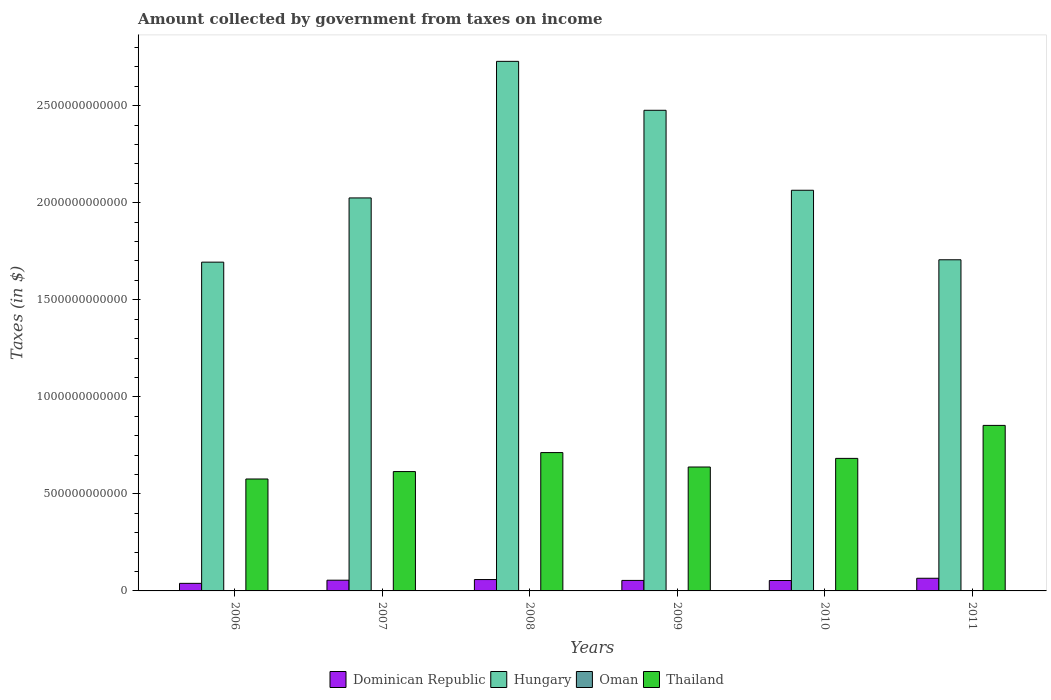How many different coloured bars are there?
Your answer should be compact. 4. How many groups of bars are there?
Your answer should be compact. 6. Are the number of bars on each tick of the X-axis equal?
Offer a terse response. Yes. How many bars are there on the 4th tick from the left?
Keep it short and to the point. 4. How many bars are there on the 3rd tick from the right?
Your answer should be compact. 4. In how many cases, is the number of bars for a given year not equal to the number of legend labels?
Give a very brief answer. 0. What is the amount collected by government from taxes on income in Thailand in 2008?
Your answer should be compact. 7.13e+11. Across all years, what is the maximum amount collected by government from taxes on income in Oman?
Offer a terse response. 3.70e+08. Across all years, what is the minimum amount collected by government from taxes on income in Hungary?
Keep it short and to the point. 1.69e+12. In which year was the amount collected by government from taxes on income in Oman maximum?
Offer a terse response. 2009. What is the total amount collected by government from taxes on income in Oman in the graph?
Provide a succinct answer. 1.43e+09. What is the difference between the amount collected by government from taxes on income in Oman in 2008 and that in 2009?
Your answer should be compact. -1.33e+08. What is the difference between the amount collected by government from taxes on income in Dominican Republic in 2007 and the amount collected by government from taxes on income in Oman in 2011?
Offer a terse response. 5.50e+1. What is the average amount collected by government from taxes on income in Dominican Republic per year?
Your response must be concise. 5.43e+1. In the year 2011, what is the difference between the amount collected by government from taxes on income in Oman and amount collected by government from taxes on income in Thailand?
Offer a very short reply. -8.52e+11. In how many years, is the amount collected by government from taxes on income in Hungary greater than 700000000000 $?
Ensure brevity in your answer.  6. What is the ratio of the amount collected by government from taxes on income in Hungary in 2006 to that in 2010?
Give a very brief answer. 0.82. Is the amount collected by government from taxes on income in Dominican Republic in 2009 less than that in 2011?
Ensure brevity in your answer.  Yes. What is the difference between the highest and the second highest amount collected by government from taxes on income in Hungary?
Provide a succinct answer. 2.52e+11. What is the difference between the highest and the lowest amount collected by government from taxes on income in Dominican Republic?
Your answer should be compact. 2.62e+1. In how many years, is the amount collected by government from taxes on income in Dominican Republic greater than the average amount collected by government from taxes on income in Dominican Republic taken over all years?
Provide a succinct answer. 3. Is the sum of the amount collected by government from taxes on income in Oman in 2009 and 2010 greater than the maximum amount collected by government from taxes on income in Thailand across all years?
Keep it short and to the point. No. Is it the case that in every year, the sum of the amount collected by government from taxes on income in Thailand and amount collected by government from taxes on income in Oman is greater than the sum of amount collected by government from taxes on income in Hungary and amount collected by government from taxes on income in Dominican Republic?
Ensure brevity in your answer.  No. What does the 1st bar from the left in 2011 represents?
Keep it short and to the point. Dominican Republic. What does the 3rd bar from the right in 2009 represents?
Offer a very short reply. Hungary. Are all the bars in the graph horizontal?
Give a very brief answer. No. What is the difference between two consecutive major ticks on the Y-axis?
Your answer should be very brief. 5.00e+11. Does the graph contain grids?
Your answer should be compact. No. How many legend labels are there?
Ensure brevity in your answer.  4. What is the title of the graph?
Your response must be concise. Amount collected by government from taxes on income. Does "Ecuador" appear as one of the legend labels in the graph?
Ensure brevity in your answer.  No. What is the label or title of the X-axis?
Give a very brief answer. Years. What is the label or title of the Y-axis?
Provide a succinct answer. Taxes (in $). What is the Taxes (in $) in Dominican Republic in 2006?
Ensure brevity in your answer.  3.90e+1. What is the Taxes (in $) in Hungary in 2006?
Provide a short and direct response. 1.69e+12. What is the Taxes (in $) in Oman in 2006?
Offer a terse response. 8.54e+07. What is the Taxes (in $) in Thailand in 2006?
Keep it short and to the point. 5.77e+11. What is the Taxes (in $) in Dominican Republic in 2007?
Your response must be concise. 5.52e+1. What is the Taxes (in $) in Hungary in 2007?
Your answer should be very brief. 2.02e+12. What is the Taxes (in $) of Oman in 2007?
Make the answer very short. 1.87e+08. What is the Taxes (in $) of Thailand in 2007?
Keep it short and to the point. 6.15e+11. What is the Taxes (in $) in Dominican Republic in 2008?
Your answer should be compact. 5.85e+1. What is the Taxes (in $) of Hungary in 2008?
Provide a succinct answer. 2.73e+12. What is the Taxes (in $) in Oman in 2008?
Provide a succinct answer. 2.37e+08. What is the Taxes (in $) of Thailand in 2008?
Keep it short and to the point. 7.13e+11. What is the Taxes (in $) of Dominican Republic in 2009?
Ensure brevity in your answer.  5.41e+1. What is the Taxes (in $) in Hungary in 2009?
Provide a short and direct response. 2.48e+12. What is the Taxes (in $) in Oman in 2009?
Make the answer very short. 3.70e+08. What is the Taxes (in $) of Thailand in 2009?
Offer a very short reply. 6.38e+11. What is the Taxes (in $) of Dominican Republic in 2010?
Your response must be concise. 5.36e+1. What is the Taxes (in $) of Hungary in 2010?
Your answer should be very brief. 2.06e+12. What is the Taxes (in $) in Oman in 2010?
Your answer should be compact. 2.73e+08. What is the Taxes (in $) of Thailand in 2010?
Keep it short and to the point. 6.83e+11. What is the Taxes (in $) in Dominican Republic in 2011?
Your answer should be very brief. 6.52e+1. What is the Taxes (in $) of Hungary in 2011?
Your response must be concise. 1.71e+12. What is the Taxes (in $) in Oman in 2011?
Keep it short and to the point. 2.82e+08. What is the Taxes (in $) in Thailand in 2011?
Ensure brevity in your answer.  8.53e+11. Across all years, what is the maximum Taxes (in $) in Dominican Republic?
Ensure brevity in your answer.  6.52e+1. Across all years, what is the maximum Taxes (in $) of Hungary?
Provide a short and direct response. 2.73e+12. Across all years, what is the maximum Taxes (in $) in Oman?
Offer a very short reply. 3.70e+08. Across all years, what is the maximum Taxes (in $) in Thailand?
Provide a short and direct response. 8.53e+11. Across all years, what is the minimum Taxes (in $) in Dominican Republic?
Keep it short and to the point. 3.90e+1. Across all years, what is the minimum Taxes (in $) in Hungary?
Ensure brevity in your answer.  1.69e+12. Across all years, what is the minimum Taxes (in $) of Oman?
Give a very brief answer. 8.54e+07. Across all years, what is the minimum Taxes (in $) in Thailand?
Offer a very short reply. 5.77e+11. What is the total Taxes (in $) of Dominican Republic in the graph?
Offer a very short reply. 3.26e+11. What is the total Taxes (in $) of Hungary in the graph?
Provide a succinct answer. 1.27e+13. What is the total Taxes (in $) of Oman in the graph?
Ensure brevity in your answer.  1.43e+09. What is the total Taxes (in $) in Thailand in the graph?
Your response must be concise. 4.08e+12. What is the difference between the Taxes (in $) in Dominican Republic in 2006 and that in 2007?
Give a very brief answer. -1.63e+1. What is the difference between the Taxes (in $) of Hungary in 2006 and that in 2007?
Give a very brief answer. -3.31e+11. What is the difference between the Taxes (in $) in Oman in 2006 and that in 2007?
Offer a terse response. -1.02e+08. What is the difference between the Taxes (in $) of Thailand in 2006 and that in 2007?
Your response must be concise. -3.82e+1. What is the difference between the Taxes (in $) of Dominican Republic in 2006 and that in 2008?
Ensure brevity in your answer.  -1.96e+1. What is the difference between the Taxes (in $) of Hungary in 2006 and that in 2008?
Offer a terse response. -1.03e+12. What is the difference between the Taxes (in $) of Oman in 2006 and that in 2008?
Give a very brief answer. -1.52e+08. What is the difference between the Taxes (in $) in Thailand in 2006 and that in 2008?
Make the answer very short. -1.36e+11. What is the difference between the Taxes (in $) of Dominican Republic in 2006 and that in 2009?
Keep it short and to the point. -1.51e+1. What is the difference between the Taxes (in $) in Hungary in 2006 and that in 2009?
Provide a succinct answer. -7.82e+11. What is the difference between the Taxes (in $) of Oman in 2006 and that in 2009?
Offer a terse response. -2.85e+08. What is the difference between the Taxes (in $) of Thailand in 2006 and that in 2009?
Provide a short and direct response. -6.17e+1. What is the difference between the Taxes (in $) in Dominican Republic in 2006 and that in 2010?
Provide a short and direct response. -1.47e+1. What is the difference between the Taxes (in $) in Hungary in 2006 and that in 2010?
Provide a succinct answer. -3.70e+11. What is the difference between the Taxes (in $) in Oman in 2006 and that in 2010?
Your answer should be very brief. -1.87e+08. What is the difference between the Taxes (in $) of Thailand in 2006 and that in 2010?
Ensure brevity in your answer.  -1.06e+11. What is the difference between the Taxes (in $) in Dominican Republic in 2006 and that in 2011?
Give a very brief answer. -2.62e+1. What is the difference between the Taxes (in $) in Hungary in 2006 and that in 2011?
Make the answer very short. -1.23e+1. What is the difference between the Taxes (in $) of Oman in 2006 and that in 2011?
Your response must be concise. -1.96e+08. What is the difference between the Taxes (in $) in Thailand in 2006 and that in 2011?
Give a very brief answer. -2.76e+11. What is the difference between the Taxes (in $) in Dominican Republic in 2007 and that in 2008?
Offer a terse response. -3.30e+09. What is the difference between the Taxes (in $) of Hungary in 2007 and that in 2008?
Keep it short and to the point. -7.04e+11. What is the difference between the Taxes (in $) in Oman in 2007 and that in 2008?
Your answer should be very brief. -5.03e+07. What is the difference between the Taxes (in $) in Thailand in 2007 and that in 2008?
Provide a succinct answer. -9.78e+1. What is the difference between the Taxes (in $) in Dominican Republic in 2007 and that in 2009?
Offer a very short reply. 1.10e+09. What is the difference between the Taxes (in $) in Hungary in 2007 and that in 2009?
Provide a short and direct response. -4.52e+11. What is the difference between the Taxes (in $) of Oman in 2007 and that in 2009?
Ensure brevity in your answer.  -1.83e+08. What is the difference between the Taxes (in $) in Thailand in 2007 and that in 2009?
Give a very brief answer. -2.35e+1. What is the difference between the Taxes (in $) in Dominican Republic in 2007 and that in 2010?
Offer a very short reply. 1.59e+09. What is the difference between the Taxes (in $) in Hungary in 2007 and that in 2010?
Keep it short and to the point. -3.95e+1. What is the difference between the Taxes (in $) of Oman in 2007 and that in 2010?
Provide a short and direct response. -8.55e+07. What is the difference between the Taxes (in $) of Thailand in 2007 and that in 2010?
Your answer should be compact. -6.80e+1. What is the difference between the Taxes (in $) in Dominican Republic in 2007 and that in 2011?
Offer a terse response. -9.97e+09. What is the difference between the Taxes (in $) of Hungary in 2007 and that in 2011?
Give a very brief answer. 3.19e+11. What is the difference between the Taxes (in $) in Oman in 2007 and that in 2011?
Your answer should be very brief. -9.48e+07. What is the difference between the Taxes (in $) in Thailand in 2007 and that in 2011?
Provide a succinct answer. -2.38e+11. What is the difference between the Taxes (in $) of Dominican Republic in 2008 and that in 2009?
Provide a succinct answer. 4.41e+09. What is the difference between the Taxes (in $) in Hungary in 2008 and that in 2009?
Make the answer very short. 2.52e+11. What is the difference between the Taxes (in $) of Oman in 2008 and that in 2009?
Give a very brief answer. -1.33e+08. What is the difference between the Taxes (in $) in Thailand in 2008 and that in 2009?
Keep it short and to the point. 7.43e+1. What is the difference between the Taxes (in $) in Dominican Republic in 2008 and that in 2010?
Your answer should be very brief. 4.89e+09. What is the difference between the Taxes (in $) of Hungary in 2008 and that in 2010?
Give a very brief answer. 6.64e+11. What is the difference between the Taxes (in $) of Oman in 2008 and that in 2010?
Make the answer very short. -3.52e+07. What is the difference between the Taxes (in $) of Thailand in 2008 and that in 2010?
Your answer should be compact. 2.98e+1. What is the difference between the Taxes (in $) in Dominican Republic in 2008 and that in 2011?
Your answer should be compact. -6.67e+09. What is the difference between the Taxes (in $) in Hungary in 2008 and that in 2011?
Ensure brevity in your answer.  1.02e+12. What is the difference between the Taxes (in $) of Oman in 2008 and that in 2011?
Ensure brevity in your answer.  -4.45e+07. What is the difference between the Taxes (in $) in Thailand in 2008 and that in 2011?
Your response must be concise. -1.40e+11. What is the difference between the Taxes (in $) in Dominican Republic in 2009 and that in 2010?
Ensure brevity in your answer.  4.84e+08. What is the difference between the Taxes (in $) in Hungary in 2009 and that in 2010?
Your answer should be very brief. 4.12e+11. What is the difference between the Taxes (in $) in Oman in 2009 and that in 2010?
Your response must be concise. 9.75e+07. What is the difference between the Taxes (in $) in Thailand in 2009 and that in 2010?
Your answer should be very brief. -4.45e+1. What is the difference between the Taxes (in $) in Dominican Republic in 2009 and that in 2011?
Offer a terse response. -1.11e+1. What is the difference between the Taxes (in $) in Hungary in 2009 and that in 2011?
Your answer should be very brief. 7.70e+11. What is the difference between the Taxes (in $) in Oman in 2009 and that in 2011?
Offer a very short reply. 8.82e+07. What is the difference between the Taxes (in $) in Thailand in 2009 and that in 2011?
Make the answer very short. -2.14e+11. What is the difference between the Taxes (in $) in Dominican Republic in 2010 and that in 2011?
Ensure brevity in your answer.  -1.16e+1. What is the difference between the Taxes (in $) in Hungary in 2010 and that in 2011?
Your answer should be very brief. 3.58e+11. What is the difference between the Taxes (in $) of Oman in 2010 and that in 2011?
Your answer should be very brief. -9.30e+06. What is the difference between the Taxes (in $) of Thailand in 2010 and that in 2011?
Your answer should be very brief. -1.70e+11. What is the difference between the Taxes (in $) of Dominican Republic in 2006 and the Taxes (in $) of Hungary in 2007?
Provide a short and direct response. -1.99e+12. What is the difference between the Taxes (in $) in Dominican Republic in 2006 and the Taxes (in $) in Oman in 2007?
Provide a succinct answer. 3.88e+1. What is the difference between the Taxes (in $) in Dominican Republic in 2006 and the Taxes (in $) in Thailand in 2007?
Offer a very short reply. -5.76e+11. What is the difference between the Taxes (in $) of Hungary in 2006 and the Taxes (in $) of Oman in 2007?
Give a very brief answer. 1.69e+12. What is the difference between the Taxes (in $) in Hungary in 2006 and the Taxes (in $) in Thailand in 2007?
Offer a terse response. 1.08e+12. What is the difference between the Taxes (in $) of Oman in 2006 and the Taxes (in $) of Thailand in 2007?
Give a very brief answer. -6.15e+11. What is the difference between the Taxes (in $) in Dominican Republic in 2006 and the Taxes (in $) in Hungary in 2008?
Provide a short and direct response. -2.69e+12. What is the difference between the Taxes (in $) in Dominican Republic in 2006 and the Taxes (in $) in Oman in 2008?
Keep it short and to the point. 3.87e+1. What is the difference between the Taxes (in $) in Dominican Republic in 2006 and the Taxes (in $) in Thailand in 2008?
Keep it short and to the point. -6.74e+11. What is the difference between the Taxes (in $) in Hungary in 2006 and the Taxes (in $) in Oman in 2008?
Provide a succinct answer. 1.69e+12. What is the difference between the Taxes (in $) in Hungary in 2006 and the Taxes (in $) in Thailand in 2008?
Provide a short and direct response. 9.81e+11. What is the difference between the Taxes (in $) of Oman in 2006 and the Taxes (in $) of Thailand in 2008?
Your answer should be very brief. -7.13e+11. What is the difference between the Taxes (in $) in Dominican Republic in 2006 and the Taxes (in $) in Hungary in 2009?
Provide a short and direct response. -2.44e+12. What is the difference between the Taxes (in $) in Dominican Republic in 2006 and the Taxes (in $) in Oman in 2009?
Your answer should be compact. 3.86e+1. What is the difference between the Taxes (in $) of Dominican Republic in 2006 and the Taxes (in $) of Thailand in 2009?
Offer a very short reply. -5.99e+11. What is the difference between the Taxes (in $) in Hungary in 2006 and the Taxes (in $) in Oman in 2009?
Provide a short and direct response. 1.69e+12. What is the difference between the Taxes (in $) in Hungary in 2006 and the Taxes (in $) in Thailand in 2009?
Your answer should be compact. 1.06e+12. What is the difference between the Taxes (in $) in Oman in 2006 and the Taxes (in $) in Thailand in 2009?
Offer a terse response. -6.38e+11. What is the difference between the Taxes (in $) of Dominican Republic in 2006 and the Taxes (in $) of Hungary in 2010?
Provide a succinct answer. -2.03e+12. What is the difference between the Taxes (in $) of Dominican Republic in 2006 and the Taxes (in $) of Oman in 2010?
Give a very brief answer. 3.87e+1. What is the difference between the Taxes (in $) of Dominican Republic in 2006 and the Taxes (in $) of Thailand in 2010?
Your answer should be very brief. -6.44e+11. What is the difference between the Taxes (in $) in Hungary in 2006 and the Taxes (in $) in Oman in 2010?
Keep it short and to the point. 1.69e+12. What is the difference between the Taxes (in $) in Hungary in 2006 and the Taxes (in $) in Thailand in 2010?
Provide a succinct answer. 1.01e+12. What is the difference between the Taxes (in $) of Oman in 2006 and the Taxes (in $) of Thailand in 2010?
Ensure brevity in your answer.  -6.83e+11. What is the difference between the Taxes (in $) in Dominican Republic in 2006 and the Taxes (in $) in Hungary in 2011?
Keep it short and to the point. -1.67e+12. What is the difference between the Taxes (in $) in Dominican Republic in 2006 and the Taxes (in $) in Oman in 2011?
Offer a very short reply. 3.87e+1. What is the difference between the Taxes (in $) of Dominican Republic in 2006 and the Taxes (in $) of Thailand in 2011?
Your answer should be compact. -8.14e+11. What is the difference between the Taxes (in $) of Hungary in 2006 and the Taxes (in $) of Oman in 2011?
Give a very brief answer. 1.69e+12. What is the difference between the Taxes (in $) of Hungary in 2006 and the Taxes (in $) of Thailand in 2011?
Make the answer very short. 8.41e+11. What is the difference between the Taxes (in $) of Oman in 2006 and the Taxes (in $) of Thailand in 2011?
Offer a terse response. -8.53e+11. What is the difference between the Taxes (in $) of Dominican Republic in 2007 and the Taxes (in $) of Hungary in 2008?
Offer a terse response. -2.67e+12. What is the difference between the Taxes (in $) in Dominican Republic in 2007 and the Taxes (in $) in Oman in 2008?
Your answer should be compact. 5.50e+1. What is the difference between the Taxes (in $) of Dominican Republic in 2007 and the Taxes (in $) of Thailand in 2008?
Ensure brevity in your answer.  -6.57e+11. What is the difference between the Taxes (in $) of Hungary in 2007 and the Taxes (in $) of Oman in 2008?
Your answer should be very brief. 2.02e+12. What is the difference between the Taxes (in $) of Hungary in 2007 and the Taxes (in $) of Thailand in 2008?
Your answer should be compact. 1.31e+12. What is the difference between the Taxes (in $) of Oman in 2007 and the Taxes (in $) of Thailand in 2008?
Provide a short and direct response. -7.13e+11. What is the difference between the Taxes (in $) of Dominican Republic in 2007 and the Taxes (in $) of Hungary in 2009?
Give a very brief answer. -2.42e+12. What is the difference between the Taxes (in $) in Dominican Republic in 2007 and the Taxes (in $) in Oman in 2009?
Your answer should be compact. 5.49e+1. What is the difference between the Taxes (in $) of Dominican Republic in 2007 and the Taxes (in $) of Thailand in 2009?
Make the answer very short. -5.83e+11. What is the difference between the Taxes (in $) in Hungary in 2007 and the Taxes (in $) in Oman in 2009?
Keep it short and to the point. 2.02e+12. What is the difference between the Taxes (in $) of Hungary in 2007 and the Taxes (in $) of Thailand in 2009?
Provide a succinct answer. 1.39e+12. What is the difference between the Taxes (in $) in Oman in 2007 and the Taxes (in $) in Thailand in 2009?
Offer a terse response. -6.38e+11. What is the difference between the Taxes (in $) of Dominican Republic in 2007 and the Taxes (in $) of Hungary in 2010?
Provide a short and direct response. -2.01e+12. What is the difference between the Taxes (in $) of Dominican Republic in 2007 and the Taxes (in $) of Oman in 2010?
Offer a terse response. 5.50e+1. What is the difference between the Taxes (in $) in Dominican Republic in 2007 and the Taxes (in $) in Thailand in 2010?
Offer a very short reply. -6.28e+11. What is the difference between the Taxes (in $) of Hungary in 2007 and the Taxes (in $) of Oman in 2010?
Offer a terse response. 2.02e+12. What is the difference between the Taxes (in $) of Hungary in 2007 and the Taxes (in $) of Thailand in 2010?
Your answer should be compact. 1.34e+12. What is the difference between the Taxes (in $) of Oman in 2007 and the Taxes (in $) of Thailand in 2010?
Offer a very short reply. -6.83e+11. What is the difference between the Taxes (in $) of Dominican Republic in 2007 and the Taxes (in $) of Hungary in 2011?
Make the answer very short. -1.65e+12. What is the difference between the Taxes (in $) of Dominican Republic in 2007 and the Taxes (in $) of Oman in 2011?
Offer a very short reply. 5.50e+1. What is the difference between the Taxes (in $) of Dominican Republic in 2007 and the Taxes (in $) of Thailand in 2011?
Provide a short and direct response. -7.98e+11. What is the difference between the Taxes (in $) of Hungary in 2007 and the Taxes (in $) of Oman in 2011?
Keep it short and to the point. 2.02e+12. What is the difference between the Taxes (in $) in Hungary in 2007 and the Taxes (in $) in Thailand in 2011?
Offer a terse response. 1.17e+12. What is the difference between the Taxes (in $) in Oman in 2007 and the Taxes (in $) in Thailand in 2011?
Provide a short and direct response. -8.53e+11. What is the difference between the Taxes (in $) of Dominican Republic in 2008 and the Taxes (in $) of Hungary in 2009?
Your answer should be very brief. -2.42e+12. What is the difference between the Taxes (in $) of Dominican Republic in 2008 and the Taxes (in $) of Oman in 2009?
Offer a terse response. 5.82e+1. What is the difference between the Taxes (in $) in Dominican Republic in 2008 and the Taxes (in $) in Thailand in 2009?
Provide a succinct answer. -5.80e+11. What is the difference between the Taxes (in $) of Hungary in 2008 and the Taxes (in $) of Oman in 2009?
Provide a succinct answer. 2.73e+12. What is the difference between the Taxes (in $) in Hungary in 2008 and the Taxes (in $) in Thailand in 2009?
Give a very brief answer. 2.09e+12. What is the difference between the Taxes (in $) of Oman in 2008 and the Taxes (in $) of Thailand in 2009?
Offer a terse response. -6.38e+11. What is the difference between the Taxes (in $) in Dominican Republic in 2008 and the Taxes (in $) in Hungary in 2010?
Ensure brevity in your answer.  -2.01e+12. What is the difference between the Taxes (in $) in Dominican Republic in 2008 and the Taxes (in $) in Oman in 2010?
Ensure brevity in your answer.  5.83e+1. What is the difference between the Taxes (in $) in Dominican Republic in 2008 and the Taxes (in $) in Thailand in 2010?
Your answer should be compact. -6.24e+11. What is the difference between the Taxes (in $) of Hungary in 2008 and the Taxes (in $) of Oman in 2010?
Ensure brevity in your answer.  2.73e+12. What is the difference between the Taxes (in $) in Hungary in 2008 and the Taxes (in $) in Thailand in 2010?
Provide a succinct answer. 2.05e+12. What is the difference between the Taxes (in $) in Oman in 2008 and the Taxes (in $) in Thailand in 2010?
Your answer should be very brief. -6.83e+11. What is the difference between the Taxes (in $) in Dominican Republic in 2008 and the Taxes (in $) in Hungary in 2011?
Offer a terse response. -1.65e+12. What is the difference between the Taxes (in $) of Dominican Republic in 2008 and the Taxes (in $) of Oman in 2011?
Give a very brief answer. 5.83e+1. What is the difference between the Taxes (in $) in Dominican Republic in 2008 and the Taxes (in $) in Thailand in 2011?
Your response must be concise. -7.94e+11. What is the difference between the Taxes (in $) of Hungary in 2008 and the Taxes (in $) of Oman in 2011?
Keep it short and to the point. 2.73e+12. What is the difference between the Taxes (in $) of Hungary in 2008 and the Taxes (in $) of Thailand in 2011?
Keep it short and to the point. 1.88e+12. What is the difference between the Taxes (in $) in Oman in 2008 and the Taxes (in $) in Thailand in 2011?
Offer a very short reply. -8.53e+11. What is the difference between the Taxes (in $) of Dominican Republic in 2009 and the Taxes (in $) of Hungary in 2010?
Provide a short and direct response. -2.01e+12. What is the difference between the Taxes (in $) in Dominican Republic in 2009 and the Taxes (in $) in Oman in 2010?
Offer a very short reply. 5.39e+1. What is the difference between the Taxes (in $) in Dominican Republic in 2009 and the Taxes (in $) in Thailand in 2010?
Keep it short and to the point. -6.29e+11. What is the difference between the Taxes (in $) in Hungary in 2009 and the Taxes (in $) in Oman in 2010?
Keep it short and to the point. 2.48e+12. What is the difference between the Taxes (in $) of Hungary in 2009 and the Taxes (in $) of Thailand in 2010?
Make the answer very short. 1.79e+12. What is the difference between the Taxes (in $) in Oman in 2009 and the Taxes (in $) in Thailand in 2010?
Give a very brief answer. -6.82e+11. What is the difference between the Taxes (in $) in Dominican Republic in 2009 and the Taxes (in $) in Hungary in 2011?
Provide a short and direct response. -1.65e+12. What is the difference between the Taxes (in $) in Dominican Republic in 2009 and the Taxes (in $) in Oman in 2011?
Your response must be concise. 5.38e+1. What is the difference between the Taxes (in $) of Dominican Republic in 2009 and the Taxes (in $) of Thailand in 2011?
Provide a short and direct response. -7.99e+11. What is the difference between the Taxes (in $) of Hungary in 2009 and the Taxes (in $) of Oman in 2011?
Make the answer very short. 2.48e+12. What is the difference between the Taxes (in $) of Hungary in 2009 and the Taxes (in $) of Thailand in 2011?
Your answer should be compact. 1.62e+12. What is the difference between the Taxes (in $) in Oman in 2009 and the Taxes (in $) in Thailand in 2011?
Make the answer very short. -8.52e+11. What is the difference between the Taxes (in $) of Dominican Republic in 2010 and the Taxes (in $) of Hungary in 2011?
Provide a short and direct response. -1.65e+12. What is the difference between the Taxes (in $) of Dominican Republic in 2010 and the Taxes (in $) of Oman in 2011?
Offer a terse response. 5.34e+1. What is the difference between the Taxes (in $) of Dominican Republic in 2010 and the Taxes (in $) of Thailand in 2011?
Offer a terse response. -7.99e+11. What is the difference between the Taxes (in $) of Hungary in 2010 and the Taxes (in $) of Oman in 2011?
Offer a terse response. 2.06e+12. What is the difference between the Taxes (in $) of Hungary in 2010 and the Taxes (in $) of Thailand in 2011?
Offer a very short reply. 1.21e+12. What is the difference between the Taxes (in $) in Oman in 2010 and the Taxes (in $) in Thailand in 2011?
Make the answer very short. -8.52e+11. What is the average Taxes (in $) in Dominican Republic per year?
Ensure brevity in your answer.  5.43e+1. What is the average Taxes (in $) of Hungary per year?
Offer a terse response. 2.12e+12. What is the average Taxes (in $) in Oman per year?
Your response must be concise. 2.39e+08. What is the average Taxes (in $) in Thailand per year?
Your answer should be very brief. 6.80e+11. In the year 2006, what is the difference between the Taxes (in $) in Dominican Republic and Taxes (in $) in Hungary?
Offer a terse response. -1.65e+12. In the year 2006, what is the difference between the Taxes (in $) of Dominican Republic and Taxes (in $) of Oman?
Make the answer very short. 3.89e+1. In the year 2006, what is the difference between the Taxes (in $) in Dominican Republic and Taxes (in $) in Thailand?
Your answer should be very brief. -5.38e+11. In the year 2006, what is the difference between the Taxes (in $) of Hungary and Taxes (in $) of Oman?
Make the answer very short. 1.69e+12. In the year 2006, what is the difference between the Taxes (in $) in Hungary and Taxes (in $) in Thailand?
Your answer should be compact. 1.12e+12. In the year 2006, what is the difference between the Taxes (in $) of Oman and Taxes (in $) of Thailand?
Your response must be concise. -5.77e+11. In the year 2007, what is the difference between the Taxes (in $) in Dominican Republic and Taxes (in $) in Hungary?
Keep it short and to the point. -1.97e+12. In the year 2007, what is the difference between the Taxes (in $) in Dominican Republic and Taxes (in $) in Oman?
Ensure brevity in your answer.  5.50e+1. In the year 2007, what is the difference between the Taxes (in $) of Dominican Republic and Taxes (in $) of Thailand?
Make the answer very short. -5.60e+11. In the year 2007, what is the difference between the Taxes (in $) of Hungary and Taxes (in $) of Oman?
Provide a short and direct response. 2.02e+12. In the year 2007, what is the difference between the Taxes (in $) in Hungary and Taxes (in $) in Thailand?
Keep it short and to the point. 1.41e+12. In the year 2007, what is the difference between the Taxes (in $) in Oman and Taxes (in $) in Thailand?
Ensure brevity in your answer.  -6.15e+11. In the year 2008, what is the difference between the Taxes (in $) of Dominican Republic and Taxes (in $) of Hungary?
Your answer should be very brief. -2.67e+12. In the year 2008, what is the difference between the Taxes (in $) in Dominican Republic and Taxes (in $) in Oman?
Make the answer very short. 5.83e+1. In the year 2008, what is the difference between the Taxes (in $) of Dominican Republic and Taxes (in $) of Thailand?
Make the answer very short. -6.54e+11. In the year 2008, what is the difference between the Taxes (in $) of Hungary and Taxes (in $) of Oman?
Your answer should be compact. 2.73e+12. In the year 2008, what is the difference between the Taxes (in $) in Hungary and Taxes (in $) in Thailand?
Make the answer very short. 2.02e+12. In the year 2008, what is the difference between the Taxes (in $) in Oman and Taxes (in $) in Thailand?
Offer a very short reply. -7.12e+11. In the year 2009, what is the difference between the Taxes (in $) in Dominican Republic and Taxes (in $) in Hungary?
Your answer should be very brief. -2.42e+12. In the year 2009, what is the difference between the Taxes (in $) of Dominican Republic and Taxes (in $) of Oman?
Your answer should be very brief. 5.38e+1. In the year 2009, what is the difference between the Taxes (in $) of Dominican Republic and Taxes (in $) of Thailand?
Your response must be concise. -5.84e+11. In the year 2009, what is the difference between the Taxes (in $) in Hungary and Taxes (in $) in Oman?
Keep it short and to the point. 2.48e+12. In the year 2009, what is the difference between the Taxes (in $) of Hungary and Taxes (in $) of Thailand?
Give a very brief answer. 1.84e+12. In the year 2009, what is the difference between the Taxes (in $) of Oman and Taxes (in $) of Thailand?
Provide a succinct answer. -6.38e+11. In the year 2010, what is the difference between the Taxes (in $) in Dominican Republic and Taxes (in $) in Hungary?
Give a very brief answer. -2.01e+12. In the year 2010, what is the difference between the Taxes (in $) of Dominican Republic and Taxes (in $) of Oman?
Ensure brevity in your answer.  5.34e+1. In the year 2010, what is the difference between the Taxes (in $) in Dominican Republic and Taxes (in $) in Thailand?
Keep it short and to the point. -6.29e+11. In the year 2010, what is the difference between the Taxes (in $) of Hungary and Taxes (in $) of Oman?
Give a very brief answer. 2.06e+12. In the year 2010, what is the difference between the Taxes (in $) of Hungary and Taxes (in $) of Thailand?
Provide a succinct answer. 1.38e+12. In the year 2010, what is the difference between the Taxes (in $) in Oman and Taxes (in $) in Thailand?
Provide a succinct answer. -6.83e+11. In the year 2011, what is the difference between the Taxes (in $) of Dominican Republic and Taxes (in $) of Hungary?
Your answer should be compact. -1.64e+12. In the year 2011, what is the difference between the Taxes (in $) in Dominican Republic and Taxes (in $) in Oman?
Your answer should be very brief. 6.49e+1. In the year 2011, what is the difference between the Taxes (in $) in Dominican Republic and Taxes (in $) in Thailand?
Make the answer very short. -7.88e+11. In the year 2011, what is the difference between the Taxes (in $) of Hungary and Taxes (in $) of Oman?
Give a very brief answer. 1.71e+12. In the year 2011, what is the difference between the Taxes (in $) of Hungary and Taxes (in $) of Thailand?
Make the answer very short. 8.53e+11. In the year 2011, what is the difference between the Taxes (in $) of Oman and Taxes (in $) of Thailand?
Provide a short and direct response. -8.52e+11. What is the ratio of the Taxes (in $) of Dominican Republic in 2006 to that in 2007?
Provide a short and direct response. 0.71. What is the ratio of the Taxes (in $) of Hungary in 2006 to that in 2007?
Provide a succinct answer. 0.84. What is the ratio of the Taxes (in $) in Oman in 2006 to that in 2007?
Your answer should be very brief. 0.46. What is the ratio of the Taxes (in $) in Thailand in 2006 to that in 2007?
Your answer should be compact. 0.94. What is the ratio of the Taxes (in $) of Dominican Republic in 2006 to that in 2008?
Provide a short and direct response. 0.67. What is the ratio of the Taxes (in $) of Hungary in 2006 to that in 2008?
Your answer should be very brief. 0.62. What is the ratio of the Taxes (in $) of Oman in 2006 to that in 2008?
Your answer should be very brief. 0.36. What is the ratio of the Taxes (in $) of Thailand in 2006 to that in 2008?
Offer a terse response. 0.81. What is the ratio of the Taxes (in $) in Dominican Republic in 2006 to that in 2009?
Keep it short and to the point. 0.72. What is the ratio of the Taxes (in $) in Hungary in 2006 to that in 2009?
Provide a short and direct response. 0.68. What is the ratio of the Taxes (in $) of Oman in 2006 to that in 2009?
Your response must be concise. 0.23. What is the ratio of the Taxes (in $) in Thailand in 2006 to that in 2009?
Provide a succinct answer. 0.9. What is the ratio of the Taxes (in $) in Dominican Republic in 2006 to that in 2010?
Ensure brevity in your answer.  0.73. What is the ratio of the Taxes (in $) of Hungary in 2006 to that in 2010?
Provide a succinct answer. 0.82. What is the ratio of the Taxes (in $) in Oman in 2006 to that in 2010?
Provide a succinct answer. 0.31. What is the ratio of the Taxes (in $) in Thailand in 2006 to that in 2010?
Your answer should be very brief. 0.84. What is the ratio of the Taxes (in $) of Dominican Republic in 2006 to that in 2011?
Provide a succinct answer. 0.6. What is the ratio of the Taxes (in $) of Hungary in 2006 to that in 2011?
Provide a short and direct response. 0.99. What is the ratio of the Taxes (in $) in Oman in 2006 to that in 2011?
Provide a succinct answer. 0.3. What is the ratio of the Taxes (in $) in Thailand in 2006 to that in 2011?
Offer a very short reply. 0.68. What is the ratio of the Taxes (in $) of Dominican Republic in 2007 to that in 2008?
Offer a very short reply. 0.94. What is the ratio of the Taxes (in $) of Hungary in 2007 to that in 2008?
Offer a terse response. 0.74. What is the ratio of the Taxes (in $) in Oman in 2007 to that in 2008?
Ensure brevity in your answer.  0.79. What is the ratio of the Taxes (in $) of Thailand in 2007 to that in 2008?
Your answer should be compact. 0.86. What is the ratio of the Taxes (in $) in Dominican Republic in 2007 to that in 2009?
Offer a very short reply. 1.02. What is the ratio of the Taxes (in $) in Hungary in 2007 to that in 2009?
Your response must be concise. 0.82. What is the ratio of the Taxes (in $) of Oman in 2007 to that in 2009?
Make the answer very short. 0.51. What is the ratio of the Taxes (in $) of Thailand in 2007 to that in 2009?
Your answer should be compact. 0.96. What is the ratio of the Taxes (in $) of Dominican Republic in 2007 to that in 2010?
Ensure brevity in your answer.  1.03. What is the ratio of the Taxes (in $) in Hungary in 2007 to that in 2010?
Provide a short and direct response. 0.98. What is the ratio of the Taxes (in $) of Oman in 2007 to that in 2010?
Keep it short and to the point. 0.69. What is the ratio of the Taxes (in $) of Thailand in 2007 to that in 2010?
Ensure brevity in your answer.  0.9. What is the ratio of the Taxes (in $) in Dominican Republic in 2007 to that in 2011?
Keep it short and to the point. 0.85. What is the ratio of the Taxes (in $) in Hungary in 2007 to that in 2011?
Provide a short and direct response. 1.19. What is the ratio of the Taxes (in $) in Oman in 2007 to that in 2011?
Offer a terse response. 0.66. What is the ratio of the Taxes (in $) in Thailand in 2007 to that in 2011?
Your response must be concise. 0.72. What is the ratio of the Taxes (in $) in Dominican Republic in 2008 to that in 2009?
Ensure brevity in your answer.  1.08. What is the ratio of the Taxes (in $) of Hungary in 2008 to that in 2009?
Provide a succinct answer. 1.1. What is the ratio of the Taxes (in $) in Oman in 2008 to that in 2009?
Give a very brief answer. 0.64. What is the ratio of the Taxes (in $) of Thailand in 2008 to that in 2009?
Offer a terse response. 1.12. What is the ratio of the Taxes (in $) of Dominican Republic in 2008 to that in 2010?
Make the answer very short. 1.09. What is the ratio of the Taxes (in $) in Hungary in 2008 to that in 2010?
Offer a very short reply. 1.32. What is the ratio of the Taxes (in $) in Oman in 2008 to that in 2010?
Your answer should be compact. 0.87. What is the ratio of the Taxes (in $) in Thailand in 2008 to that in 2010?
Offer a very short reply. 1.04. What is the ratio of the Taxes (in $) in Dominican Republic in 2008 to that in 2011?
Your answer should be compact. 0.9. What is the ratio of the Taxes (in $) of Hungary in 2008 to that in 2011?
Your answer should be compact. 1.6. What is the ratio of the Taxes (in $) of Oman in 2008 to that in 2011?
Provide a short and direct response. 0.84. What is the ratio of the Taxes (in $) in Thailand in 2008 to that in 2011?
Ensure brevity in your answer.  0.84. What is the ratio of the Taxes (in $) in Dominican Republic in 2009 to that in 2010?
Your answer should be very brief. 1.01. What is the ratio of the Taxes (in $) of Hungary in 2009 to that in 2010?
Your answer should be very brief. 1.2. What is the ratio of the Taxes (in $) of Oman in 2009 to that in 2010?
Provide a succinct answer. 1.36. What is the ratio of the Taxes (in $) of Thailand in 2009 to that in 2010?
Give a very brief answer. 0.93. What is the ratio of the Taxes (in $) in Dominican Republic in 2009 to that in 2011?
Offer a very short reply. 0.83. What is the ratio of the Taxes (in $) in Hungary in 2009 to that in 2011?
Your response must be concise. 1.45. What is the ratio of the Taxes (in $) in Oman in 2009 to that in 2011?
Your answer should be very brief. 1.31. What is the ratio of the Taxes (in $) in Thailand in 2009 to that in 2011?
Your answer should be very brief. 0.75. What is the ratio of the Taxes (in $) of Dominican Republic in 2010 to that in 2011?
Give a very brief answer. 0.82. What is the ratio of the Taxes (in $) of Hungary in 2010 to that in 2011?
Keep it short and to the point. 1.21. What is the ratio of the Taxes (in $) of Oman in 2010 to that in 2011?
Give a very brief answer. 0.97. What is the ratio of the Taxes (in $) in Thailand in 2010 to that in 2011?
Your response must be concise. 0.8. What is the difference between the highest and the second highest Taxes (in $) in Dominican Republic?
Your answer should be very brief. 6.67e+09. What is the difference between the highest and the second highest Taxes (in $) in Hungary?
Provide a short and direct response. 2.52e+11. What is the difference between the highest and the second highest Taxes (in $) in Oman?
Your response must be concise. 8.82e+07. What is the difference between the highest and the second highest Taxes (in $) of Thailand?
Give a very brief answer. 1.40e+11. What is the difference between the highest and the lowest Taxes (in $) of Dominican Republic?
Keep it short and to the point. 2.62e+1. What is the difference between the highest and the lowest Taxes (in $) of Hungary?
Provide a short and direct response. 1.03e+12. What is the difference between the highest and the lowest Taxes (in $) of Oman?
Your answer should be compact. 2.85e+08. What is the difference between the highest and the lowest Taxes (in $) of Thailand?
Provide a succinct answer. 2.76e+11. 